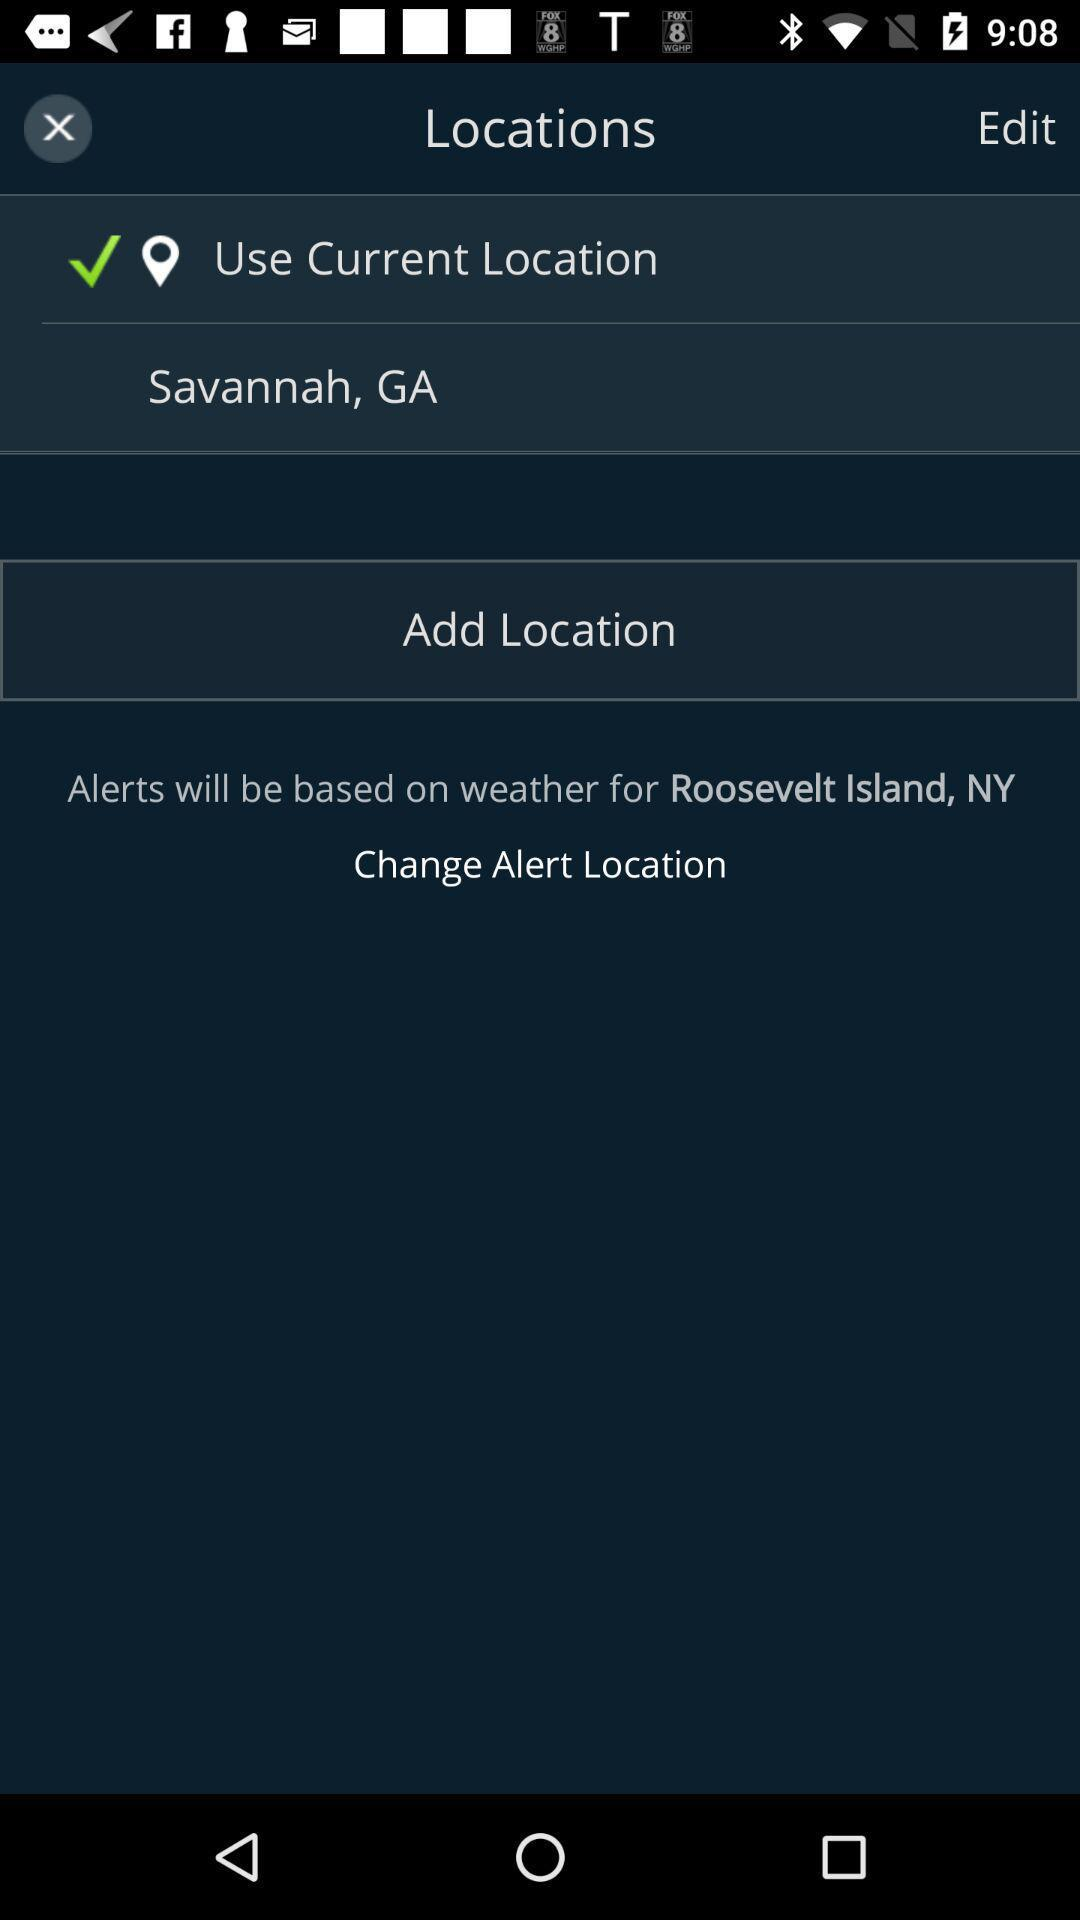What is the selected option? The selected option is "Use Current Location". 